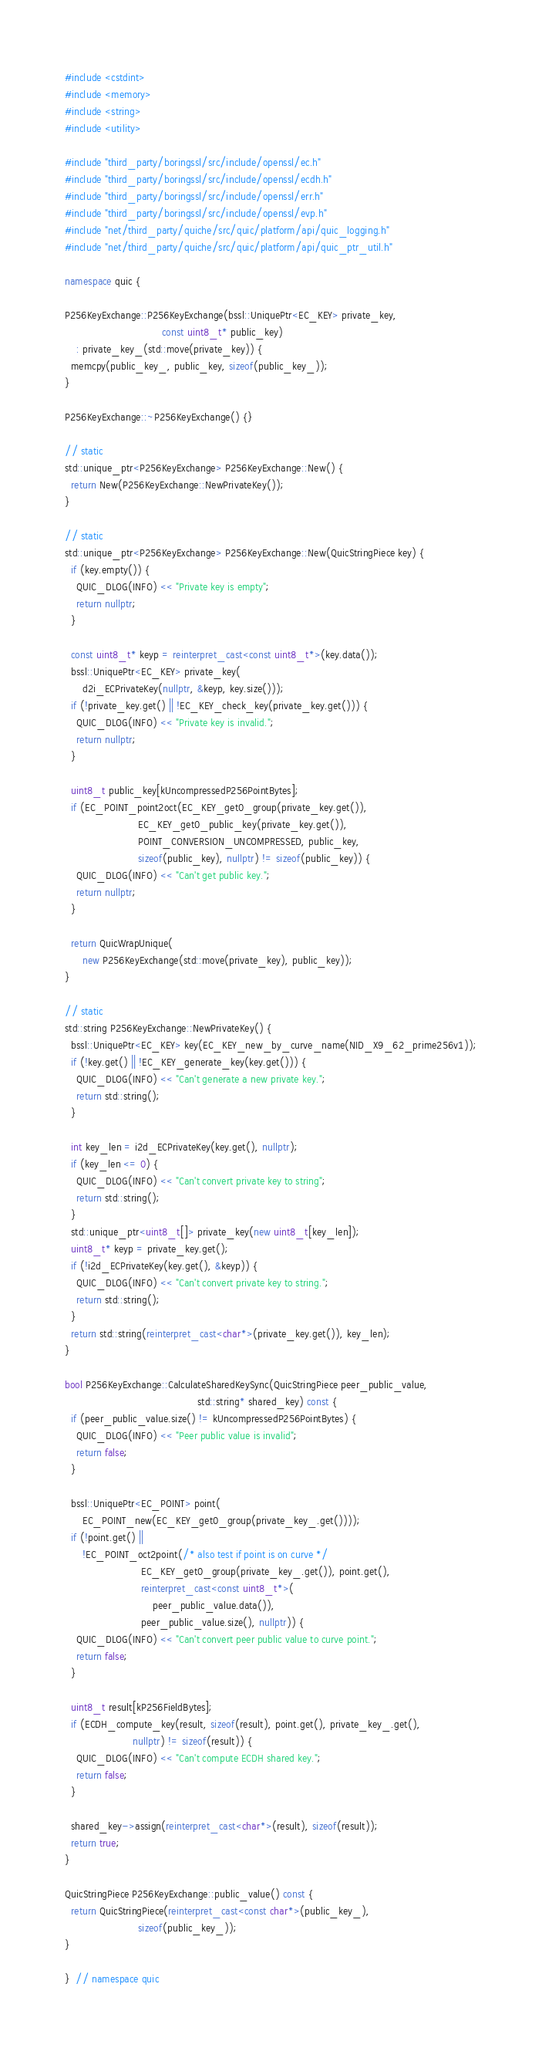Convert code to text. <code><loc_0><loc_0><loc_500><loc_500><_C++_>#include <cstdint>
#include <memory>
#include <string>
#include <utility>

#include "third_party/boringssl/src/include/openssl/ec.h"
#include "third_party/boringssl/src/include/openssl/ecdh.h"
#include "third_party/boringssl/src/include/openssl/err.h"
#include "third_party/boringssl/src/include/openssl/evp.h"
#include "net/third_party/quiche/src/quic/platform/api/quic_logging.h"
#include "net/third_party/quiche/src/quic/platform/api/quic_ptr_util.h"

namespace quic {

P256KeyExchange::P256KeyExchange(bssl::UniquePtr<EC_KEY> private_key,
                                 const uint8_t* public_key)
    : private_key_(std::move(private_key)) {
  memcpy(public_key_, public_key, sizeof(public_key_));
}

P256KeyExchange::~P256KeyExchange() {}

// static
std::unique_ptr<P256KeyExchange> P256KeyExchange::New() {
  return New(P256KeyExchange::NewPrivateKey());
}

// static
std::unique_ptr<P256KeyExchange> P256KeyExchange::New(QuicStringPiece key) {
  if (key.empty()) {
    QUIC_DLOG(INFO) << "Private key is empty";
    return nullptr;
  }

  const uint8_t* keyp = reinterpret_cast<const uint8_t*>(key.data());
  bssl::UniquePtr<EC_KEY> private_key(
      d2i_ECPrivateKey(nullptr, &keyp, key.size()));
  if (!private_key.get() || !EC_KEY_check_key(private_key.get())) {
    QUIC_DLOG(INFO) << "Private key is invalid.";
    return nullptr;
  }

  uint8_t public_key[kUncompressedP256PointBytes];
  if (EC_POINT_point2oct(EC_KEY_get0_group(private_key.get()),
                         EC_KEY_get0_public_key(private_key.get()),
                         POINT_CONVERSION_UNCOMPRESSED, public_key,
                         sizeof(public_key), nullptr) != sizeof(public_key)) {
    QUIC_DLOG(INFO) << "Can't get public key.";
    return nullptr;
  }

  return QuicWrapUnique(
      new P256KeyExchange(std::move(private_key), public_key));
}

// static
std::string P256KeyExchange::NewPrivateKey() {
  bssl::UniquePtr<EC_KEY> key(EC_KEY_new_by_curve_name(NID_X9_62_prime256v1));
  if (!key.get() || !EC_KEY_generate_key(key.get())) {
    QUIC_DLOG(INFO) << "Can't generate a new private key.";
    return std::string();
  }

  int key_len = i2d_ECPrivateKey(key.get(), nullptr);
  if (key_len <= 0) {
    QUIC_DLOG(INFO) << "Can't convert private key to string";
    return std::string();
  }
  std::unique_ptr<uint8_t[]> private_key(new uint8_t[key_len]);
  uint8_t* keyp = private_key.get();
  if (!i2d_ECPrivateKey(key.get(), &keyp)) {
    QUIC_DLOG(INFO) << "Can't convert private key to string.";
    return std::string();
  }
  return std::string(reinterpret_cast<char*>(private_key.get()), key_len);
}

bool P256KeyExchange::CalculateSharedKeySync(QuicStringPiece peer_public_value,
                                             std::string* shared_key) const {
  if (peer_public_value.size() != kUncompressedP256PointBytes) {
    QUIC_DLOG(INFO) << "Peer public value is invalid";
    return false;
  }

  bssl::UniquePtr<EC_POINT> point(
      EC_POINT_new(EC_KEY_get0_group(private_key_.get())));
  if (!point.get() ||
      !EC_POINT_oct2point(/* also test if point is on curve */
                          EC_KEY_get0_group(private_key_.get()), point.get(),
                          reinterpret_cast<const uint8_t*>(
                              peer_public_value.data()),
                          peer_public_value.size(), nullptr)) {
    QUIC_DLOG(INFO) << "Can't convert peer public value to curve point.";
    return false;
  }

  uint8_t result[kP256FieldBytes];
  if (ECDH_compute_key(result, sizeof(result), point.get(), private_key_.get(),
                       nullptr) != sizeof(result)) {
    QUIC_DLOG(INFO) << "Can't compute ECDH shared key.";
    return false;
  }

  shared_key->assign(reinterpret_cast<char*>(result), sizeof(result));
  return true;
}

QuicStringPiece P256KeyExchange::public_value() const {
  return QuicStringPiece(reinterpret_cast<const char*>(public_key_),
                         sizeof(public_key_));
}

}  // namespace quic
</code> 